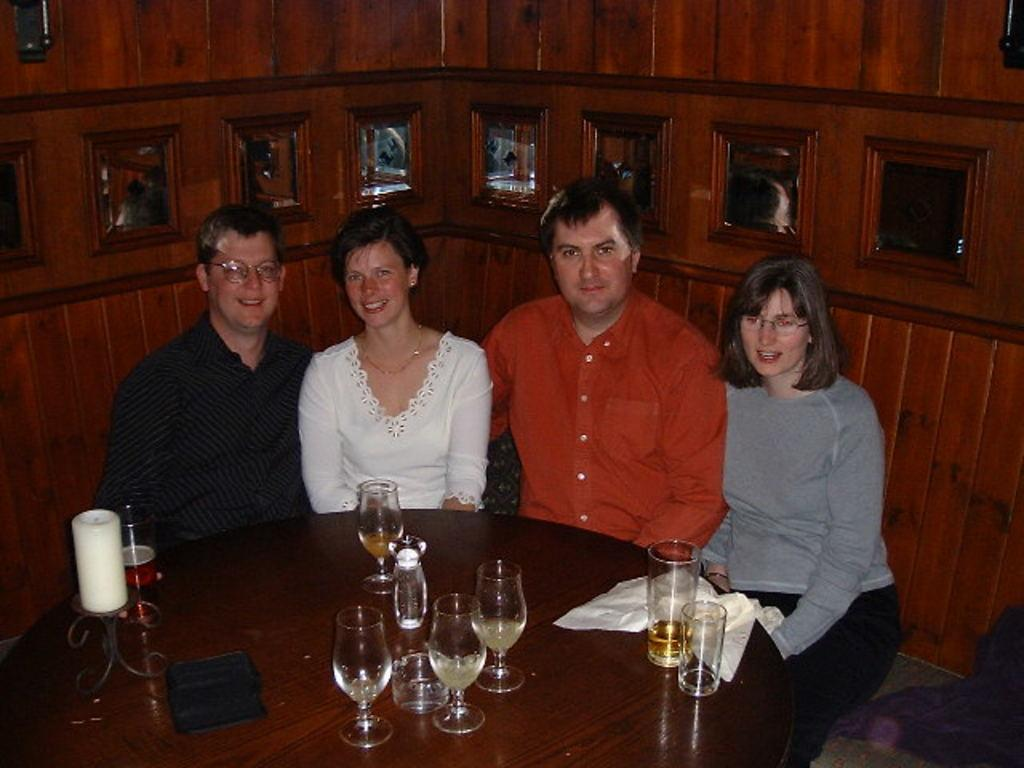How many people are sitting on the sofa in the image? There are four persons sitting on the sofa in the image. What is located in front of the sofa? The sofa is in front of a table. What can be seen on the table? There are drinking glasses, empty glasses, a candle with a stand, and tissue paper on the table. Is the sofa sinking into the quicksand in the image? There is no quicksand present in the image, and the sofa is not sinking. Who is the representative of the group sitting on the sofa in the image? The image does not provide information about a representative for the group sitting on the sofa. 